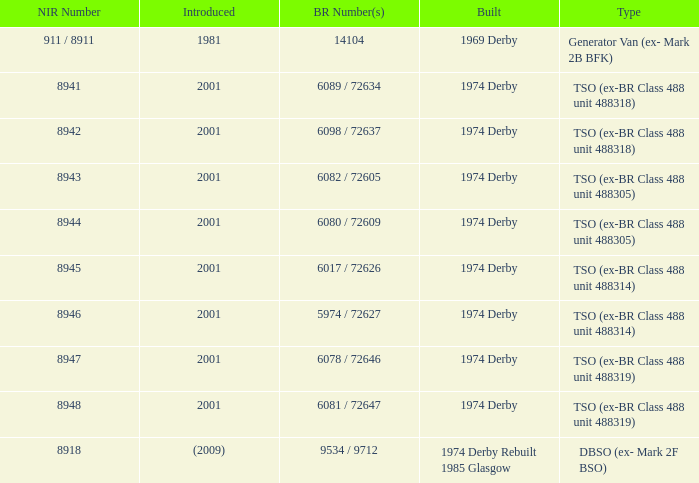Which NIR number is for the tso (ex-br class 488 unit 488305) type that has a 6082 / 72605 BR number? 8943.0. 